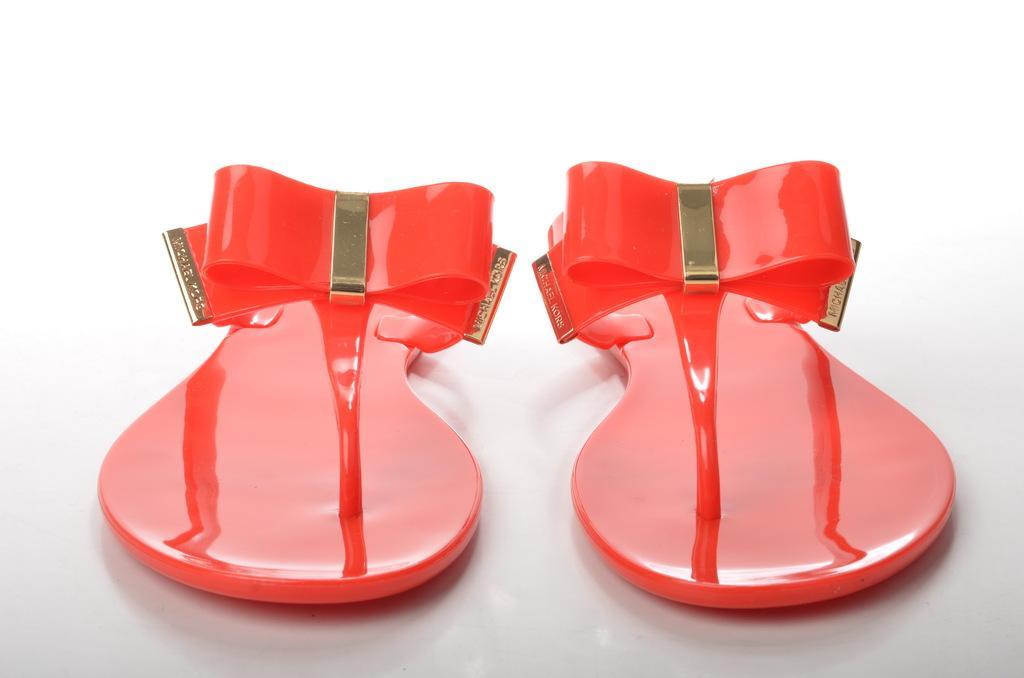Describe this image in one or two sentences. In this picture we can see a pair of red color sandals on the white object. 